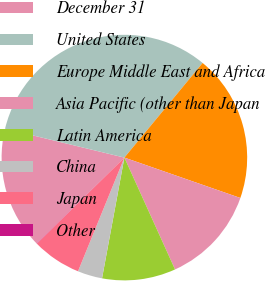Convert chart. <chart><loc_0><loc_0><loc_500><loc_500><pie_chart><fcel>December 31<fcel>United States<fcel>Europe Middle East and Africa<fcel>Asia Pacific (other than Japan<fcel>Latin America<fcel>China<fcel>Japan<fcel>Other<nl><fcel>16.12%<fcel>32.21%<fcel>19.34%<fcel>12.9%<fcel>9.68%<fcel>3.25%<fcel>6.47%<fcel>0.03%<nl></chart> 